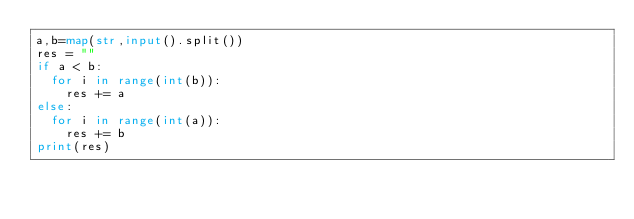<code> <loc_0><loc_0><loc_500><loc_500><_Python_>a,b=map(str,input().split())
res = ""
if a < b:
  for i in range(int(b)):
    res += a
else:
  for i in range(int(a)):
    res += b
print(res)</code> 